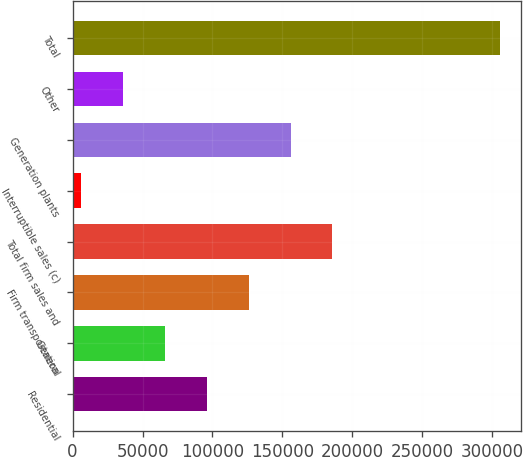Convert chart. <chart><loc_0><loc_0><loc_500><loc_500><bar_chart><fcel>Residential<fcel>General<fcel>Firm transportation<fcel>Total firm sales and<fcel>Interruptible sales (c)<fcel>Generation plants<fcel>Other<fcel>Total<nl><fcel>96018.8<fcel>66123.2<fcel>125914<fcel>185706<fcel>6332<fcel>155810<fcel>36227.6<fcel>305288<nl></chart> 